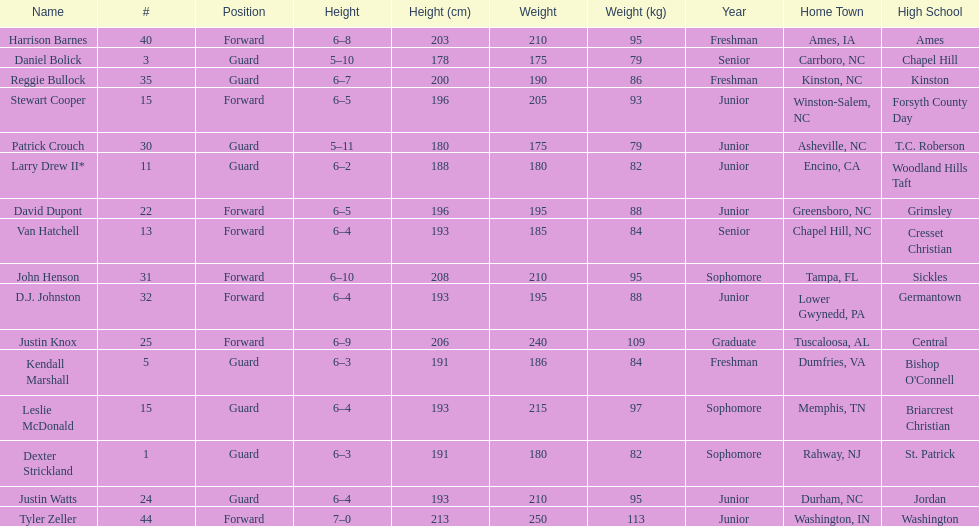Total number of players whose home town was in north carolina (nc) 7. 